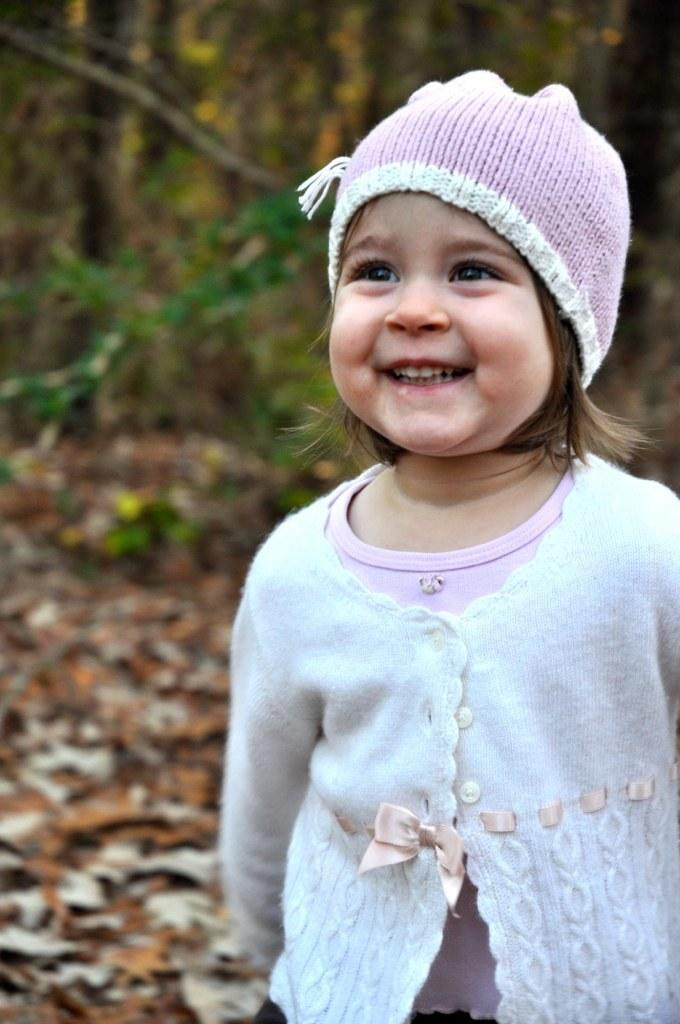Who is the main subject in the image? There is a girl in the image. Where is the girl positioned in the image? The girl is standing towards the right side of the image. What is the girl wearing on her head? The girl is wearing a cap. What can be seen on the ground in the image? There are dried leaves on the ground in the image. What is visible in the background of the image? There are trees in the background of the image. How many boats are visible in the image? There are no boats present in the image. What type of food is being served in the lunchroom in the image? There is no lunchroom present in the image. 